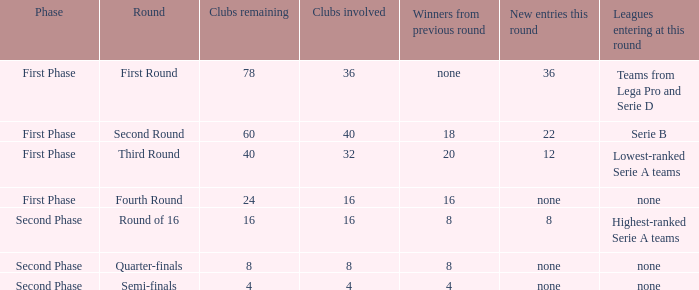With 8 clubs participating, what figure can be derived from the previous round's victorious teams? 8.0. 